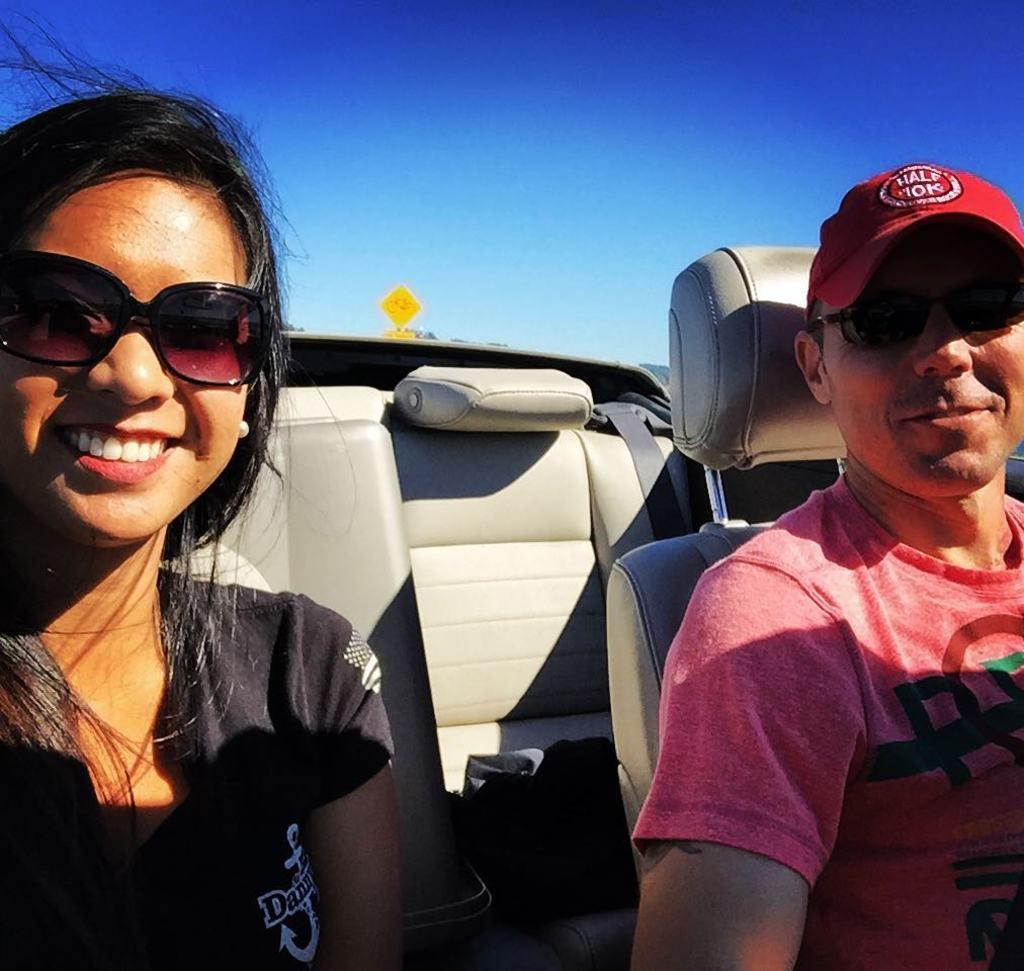Please provide a concise description of this image. There are women and men sitting inside the car. The car seats is of cream in color. The women is wearing goggles and top with black color,and the men is wearing T-shirt of orange color and a red cap with goggles. 